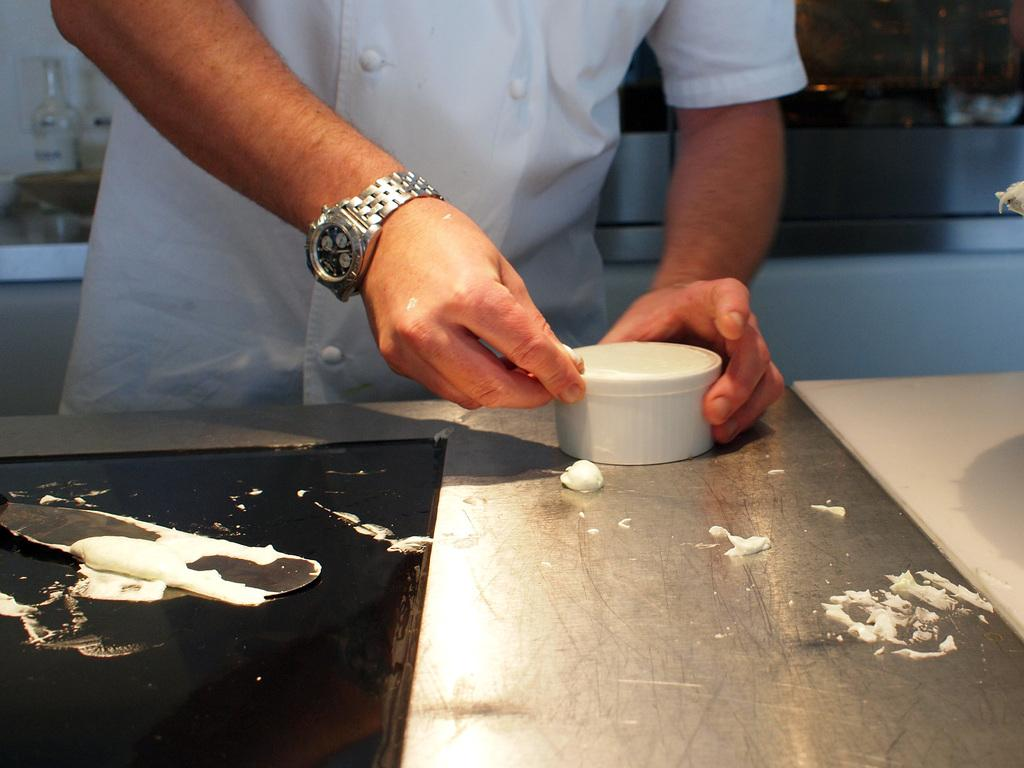What part of the human body is visible in the image? There is a human hand in the image. What is the hand wearing? The hand is wearing a watch. What type of furniture is present in the image? There is a table in the image. What object is on the table? There is a small box on the table. What type of bean is being used as a prop in the scene? There is no bean present in the image, and no scene is depicted. 